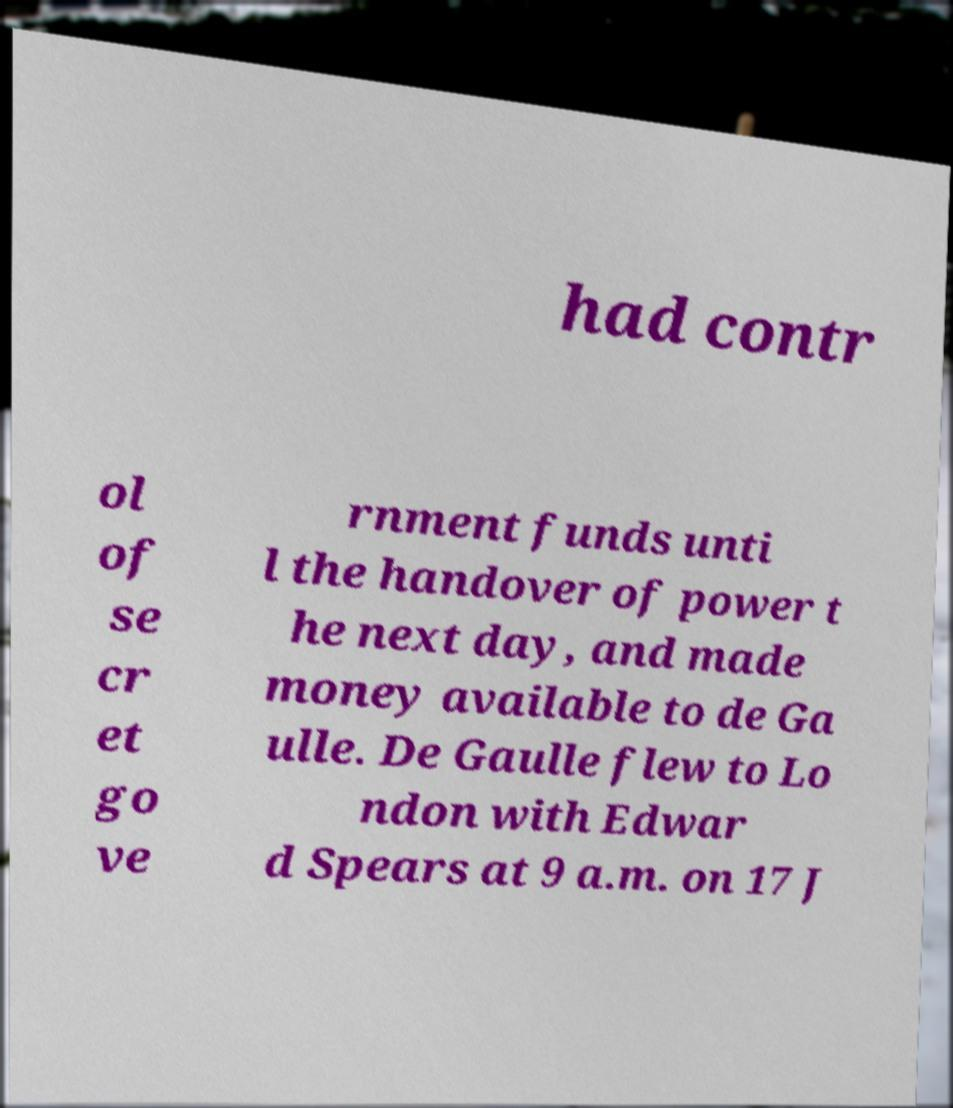Could you extract and type out the text from this image? had contr ol of se cr et go ve rnment funds unti l the handover of power t he next day, and made money available to de Ga ulle. De Gaulle flew to Lo ndon with Edwar d Spears at 9 a.m. on 17 J 